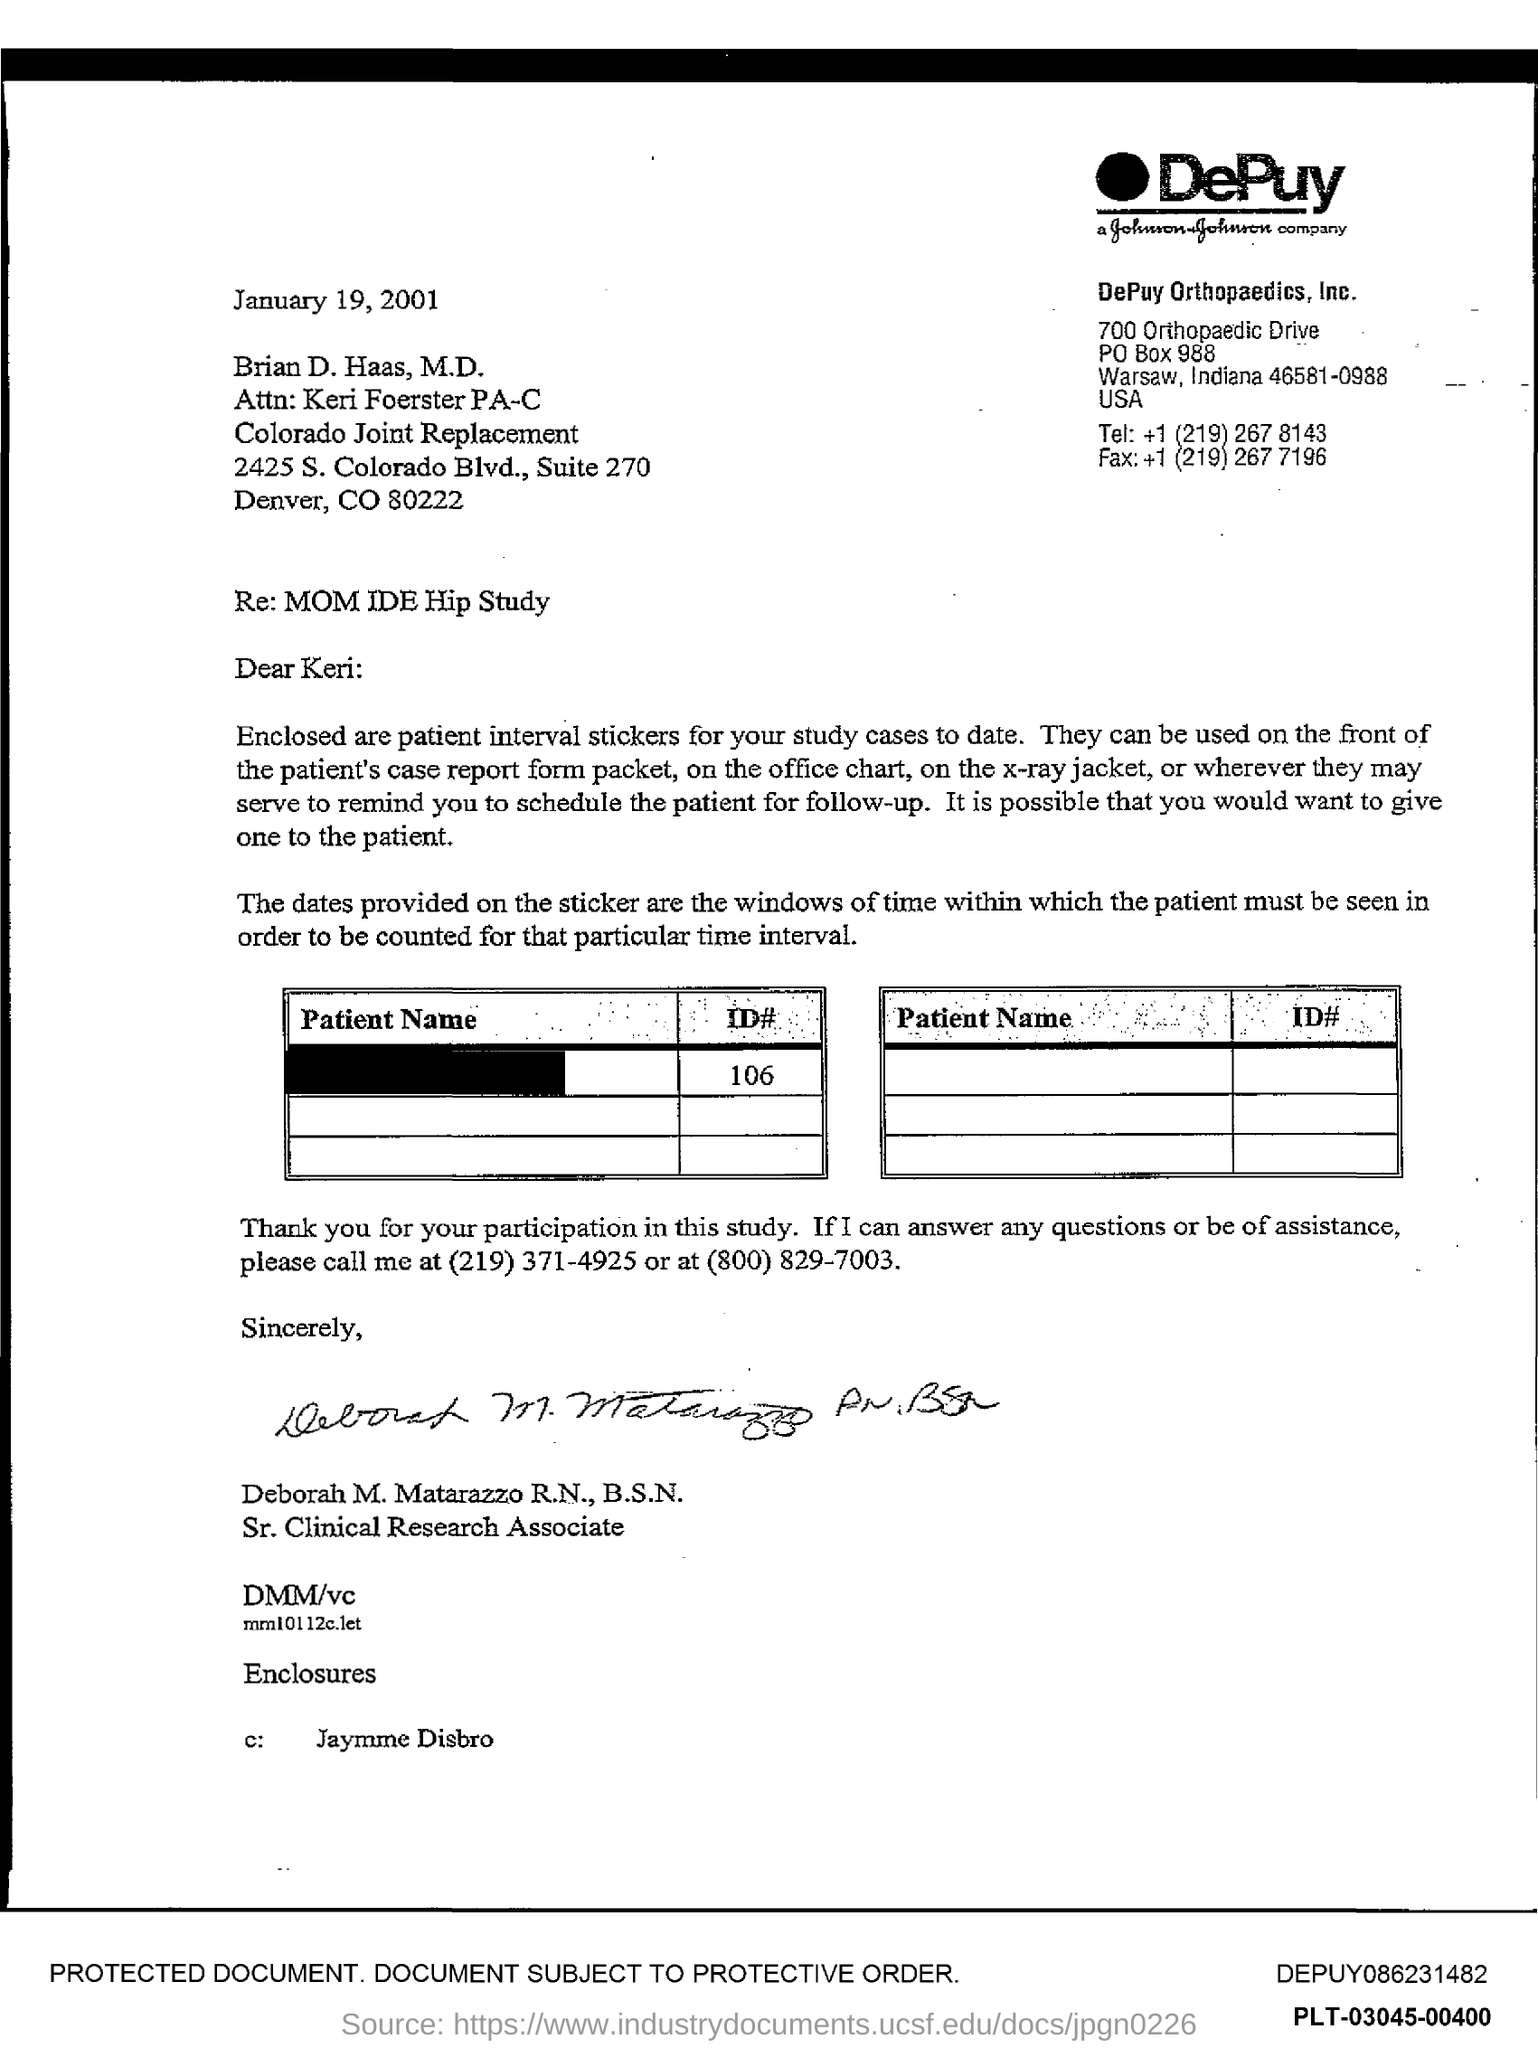What is the PO Box Number mentioned in the document?
Provide a succinct answer. 988. 